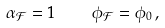<formula> <loc_0><loc_0><loc_500><loc_500>\alpha _ { \mathcal { F } } = 1 \quad \phi _ { \mathcal { F } } = \phi _ { 0 } \, ,</formula> 